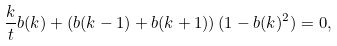<formula> <loc_0><loc_0><loc_500><loc_500>\frac { k } { t } b ( k ) + \left ( b ( k - 1 ) + b ( k + 1 ) \right ) ( 1 - b ( k ) ^ { 2 } ) = 0 ,</formula> 